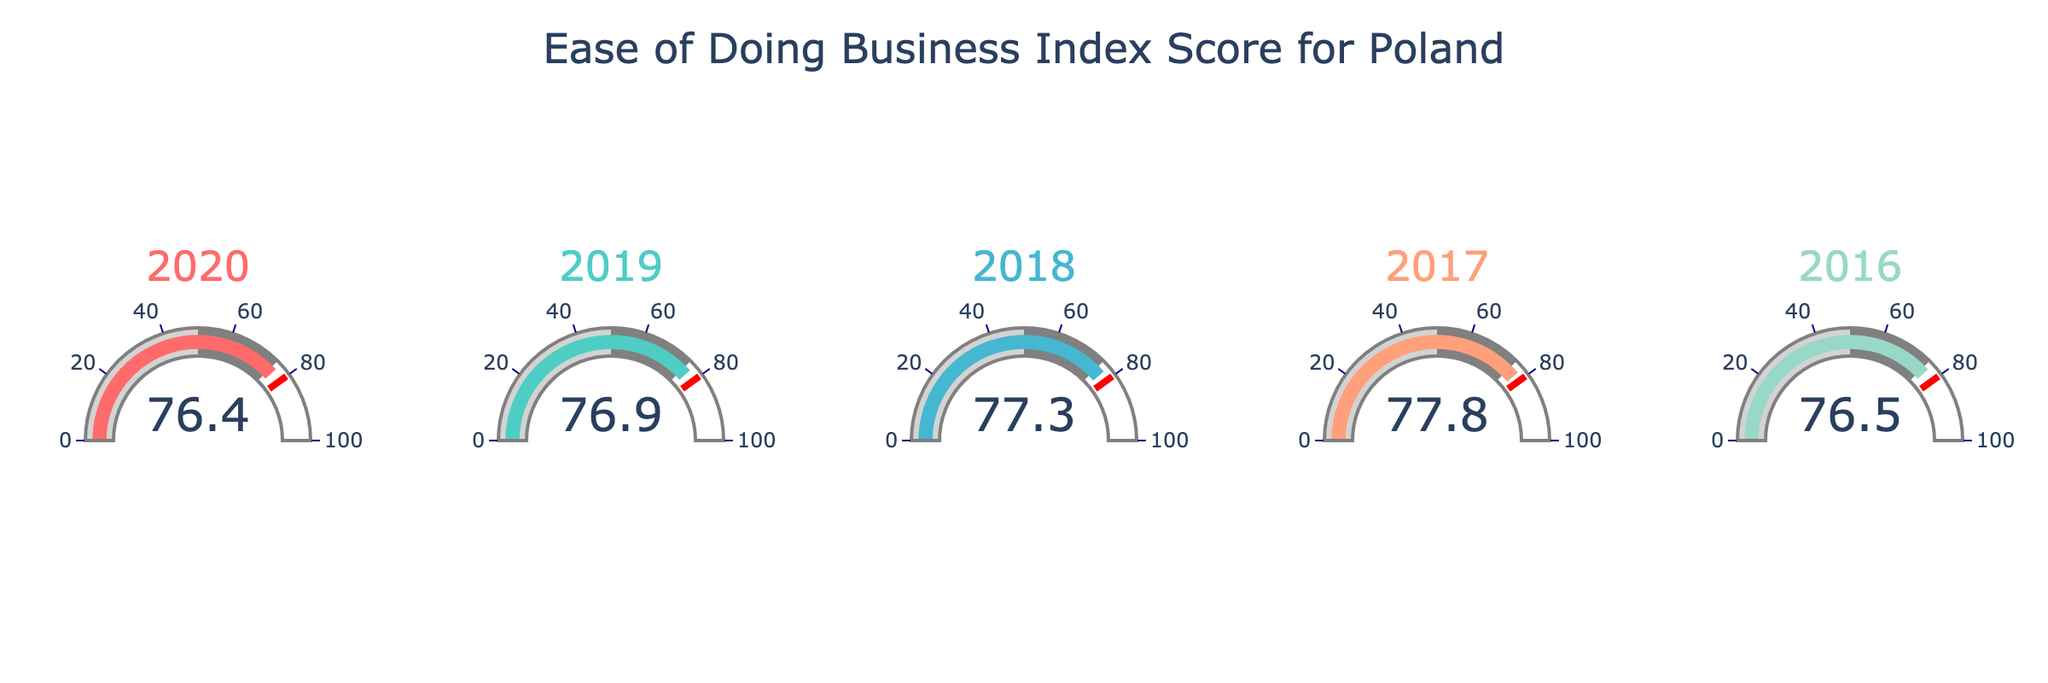What's the title of the chart? The title is prominently displayed at the top of the chart.
Answer: Ease of Doing Business Index Score for Poland What is the Ease of Doing Business Index Score for Poland in 2018? Look for the gauge corresponding to the year 2018 and read the value.
Answer: 77.3 In which year did Poland have the lowest Ease of Doing Business Index Score? Compare the values across all gauges and identify the smallest one.
Answer: 2020 By how much did the Ease of Doing Business Index Score decrease from 2017 to 2020? Subtract the 2020 score from the 2017 score. 77.8 - 76.4 = 1.4
Answer: 1.4 Which year had a higher Ease of Doing Business Index Score, 2019 or 2020? Compare the values of the gauges for 2019 and 2020.
Answer: 2019 What's the average Ease of Doing Business Index Score for Poland from 2016 to 2020? Add all the scores from 2016 to 2020 and divide by the number of years. (76.5 + 77.8 + 77.3 + 76.9 + 76.4) / 5 = 77.0
Answer: 77.0 How many years had a score above 77.0? Count the gauges with values above 77.0.
Answer: 2 (2017 and 2018) Which year’s gauge has the bar color closest to light cyan? Observe the colors of the bars and identify the one closest to light cyan (#445D53).
Answer: 2018 What is the main color used for the 2017 gauge bar? Look for the bar color in the 2017 gauge.
Answer: #45B7D1 (Cyan) Was there any year that had a threshold alarm? Check if any gauge shows a reading coinciding with the threshold marker.
Answer: No 